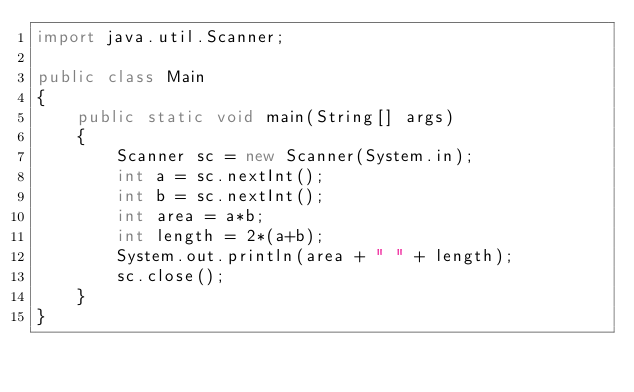Convert code to text. <code><loc_0><loc_0><loc_500><loc_500><_Java_>import java.util.Scanner;

public class Main
{
    public static void main(String[] args)
    {
        Scanner sc = new Scanner(System.in);
        int a = sc.nextInt();
        int b = sc.nextInt();
        int area = a*b;
        int length = 2*(a+b);
        System.out.println(area + " " + length);
        sc.close();
    }
}

</code> 